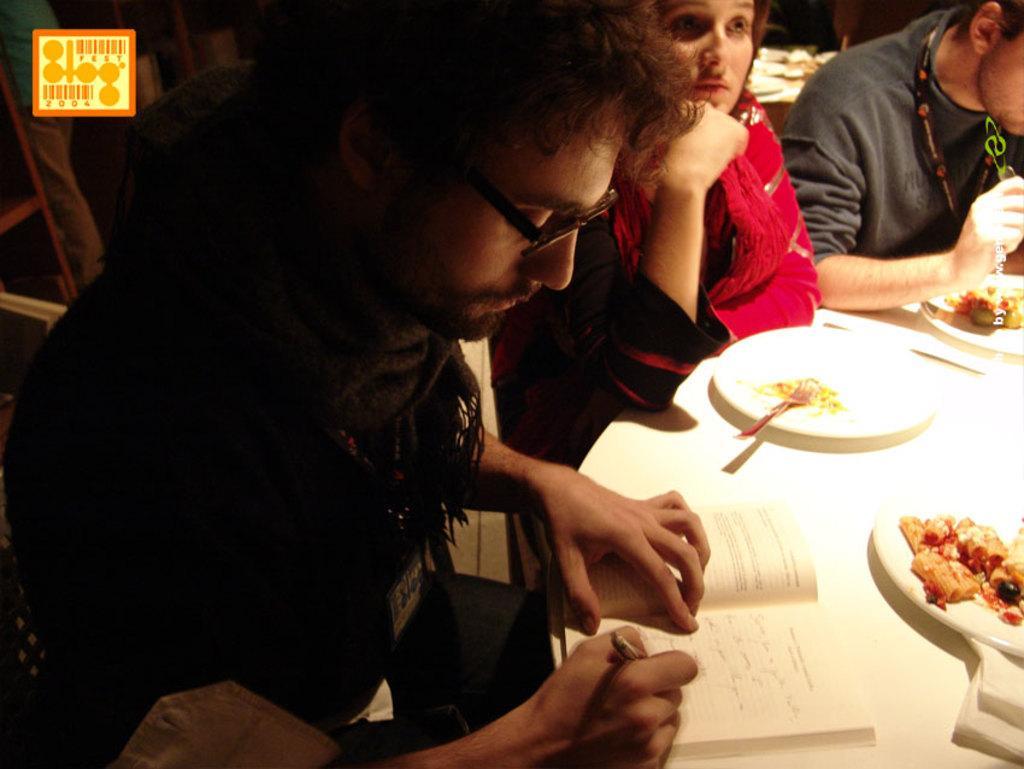How would you summarize this image in a sentence or two? In this image we can see there are people sitting and one person holding a pen, in front of them, we can see the table, on that there are plates, book, papers, spoon and some food items. At the back we can see the person standing and the object looks like a stand. 